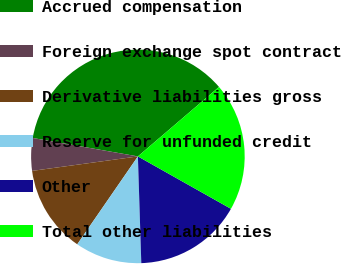Convert chart to OTSL. <chart><loc_0><loc_0><loc_500><loc_500><pie_chart><fcel>Accrued compensation<fcel>Foreign exchange spot contract<fcel>Derivative liabilities gross<fcel>Reserve for unfunded credit<fcel>Other<fcel>Total other liabilities<nl><fcel>35.97%<fcel>4.93%<fcel>13.22%<fcel>10.12%<fcel>16.33%<fcel>19.43%<nl></chart> 